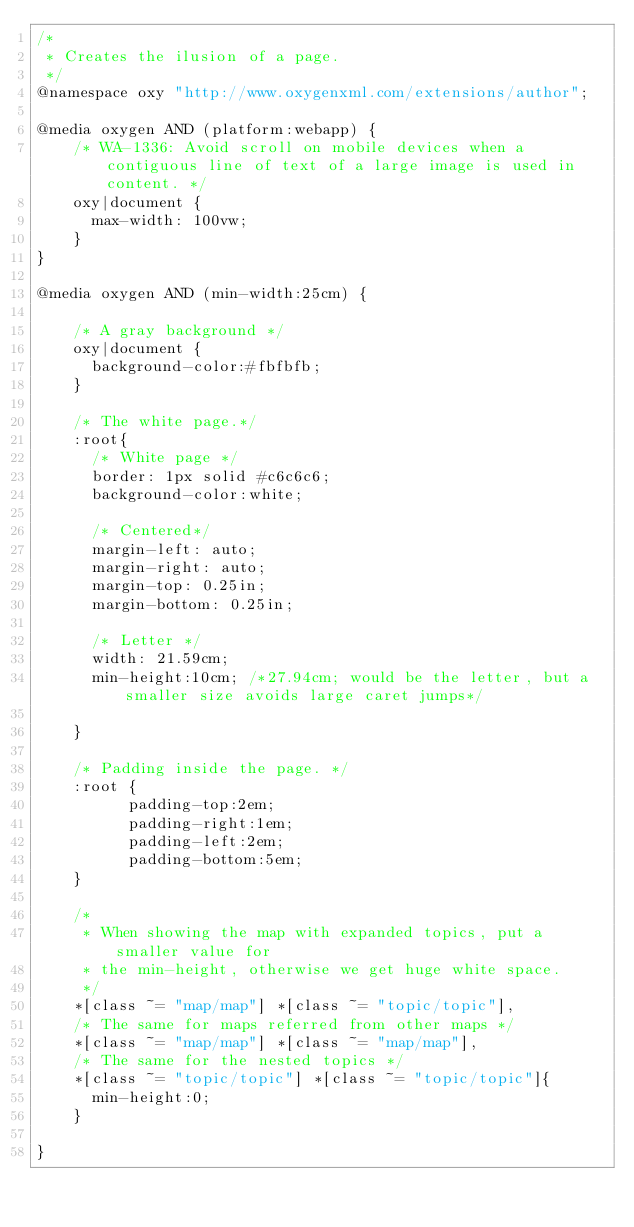Convert code to text. <code><loc_0><loc_0><loc_500><loc_500><_CSS_>/*
 * Creates the ilusion of a page.
 */
@namespace oxy "http://www.oxygenxml.com/extensions/author";

@media oxygen AND (platform:webapp) {
    /* WA-1336: Avoid scroll on mobile devices when a contiguous line of text of a large image is used in content. */
    oxy|document {
      max-width: 100vw;
    }
}    

@media oxygen AND (min-width:25cm) {

    /* A gray background */
    oxy|document {
      background-color:#fbfbfb;
    }
    
    /* The white page.*/
    :root{      
      /* White page */
      border: 1px solid #c6c6c6;
      background-color:white;
      
      /* Centered*/
      margin-left: auto;
      margin-right: auto;
      margin-top: 0.25in;
      margin-bottom: 0.25in;
      
      /* Letter */
      width: 21.59cm; 
      min-height:10cm; /*27.94cm; would be the letter, but a smaller size avoids large caret jumps*/
      
    }
    
    /* Padding inside the page. */
    :root {
          padding-top:2em;
          padding-right:1em;
          padding-left:2em;
          padding-bottom:5em;
    }

    /*
     * When showing the map with expanded topics, put a smaller value for 
     * the min-height, otherwise we get huge white space.
     */
    *[class ~= "map/map"] *[class ~= "topic/topic"],
    /* The same for maps referred from other maps */
    *[class ~= "map/map"] *[class ~= "map/map"], 
    /* The same for the nested topics */
    *[class ~= "topic/topic"] *[class ~= "topic/topic"]{
      min-height:0;  
    }
    
}




</code> 